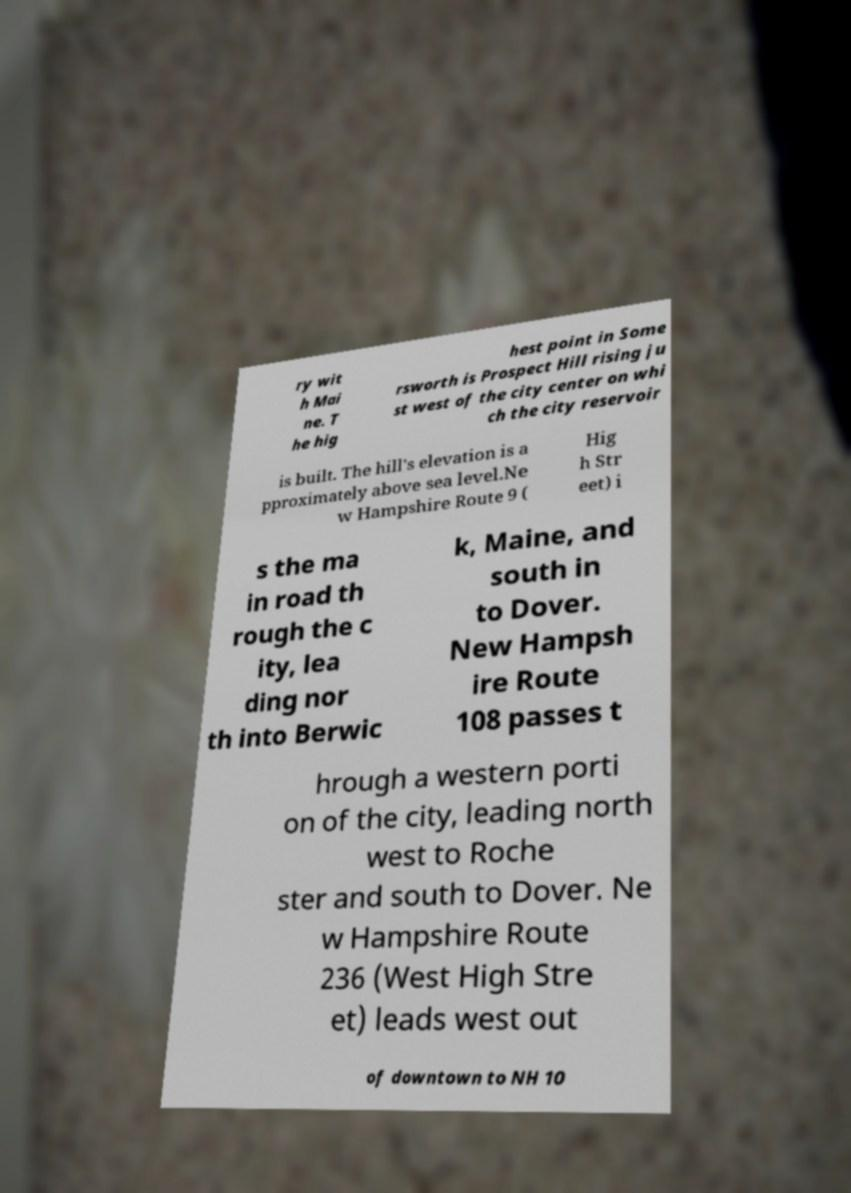There's text embedded in this image that I need extracted. Can you transcribe it verbatim? ry wit h Mai ne. T he hig hest point in Some rsworth is Prospect Hill rising ju st west of the city center on whi ch the city reservoir is built. The hill's elevation is a pproximately above sea level.Ne w Hampshire Route 9 ( Hig h Str eet) i s the ma in road th rough the c ity, lea ding nor th into Berwic k, Maine, and south in to Dover. New Hampsh ire Route 108 passes t hrough a western porti on of the city, leading north west to Roche ster and south to Dover. Ne w Hampshire Route 236 (West High Stre et) leads west out of downtown to NH 10 